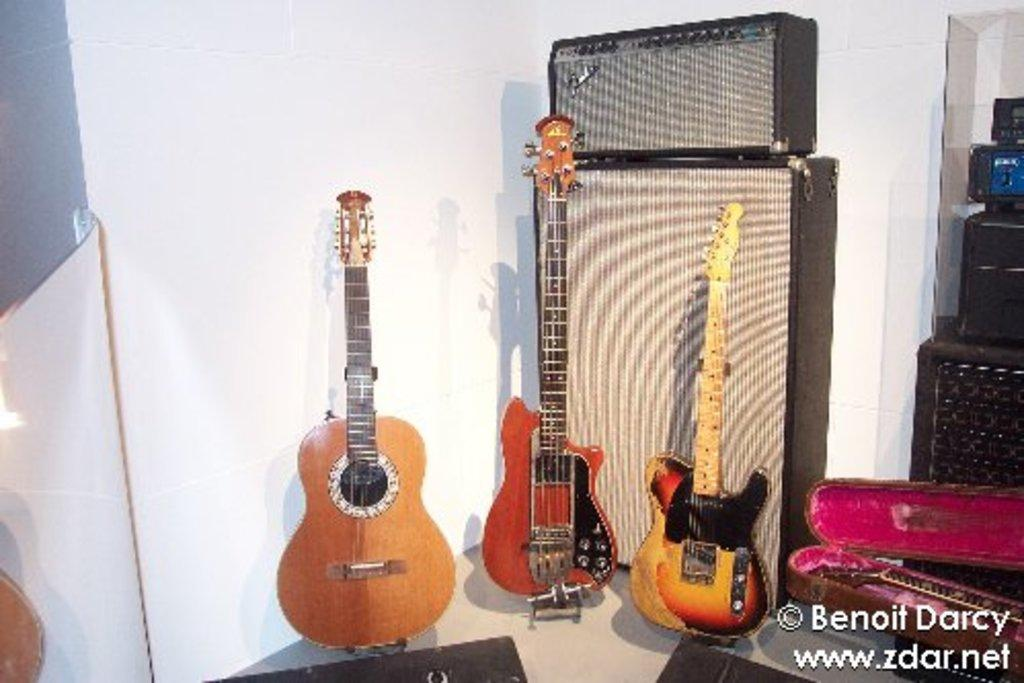How many musical instruments can be seen in the image? There are three musical instruments in the image. What type of environment is depicted in the image? The setting appears to be a musical room. Where is the basket located in the image? There is no basket present in the image. What type of performance might be happening on the stage in the image? There is no stage present in the image. 